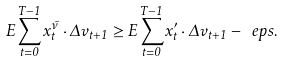<formula> <loc_0><loc_0><loc_500><loc_500>E \sum _ { t = 0 } ^ { T - 1 } x ^ { \bar { \nu } } _ { t } \cdot \Delta v _ { t + 1 } \geq E \sum _ { t = 0 } ^ { T - 1 } x ^ { \prime } _ { t } \cdot \Delta v _ { t + 1 } - \ e p s .</formula> 